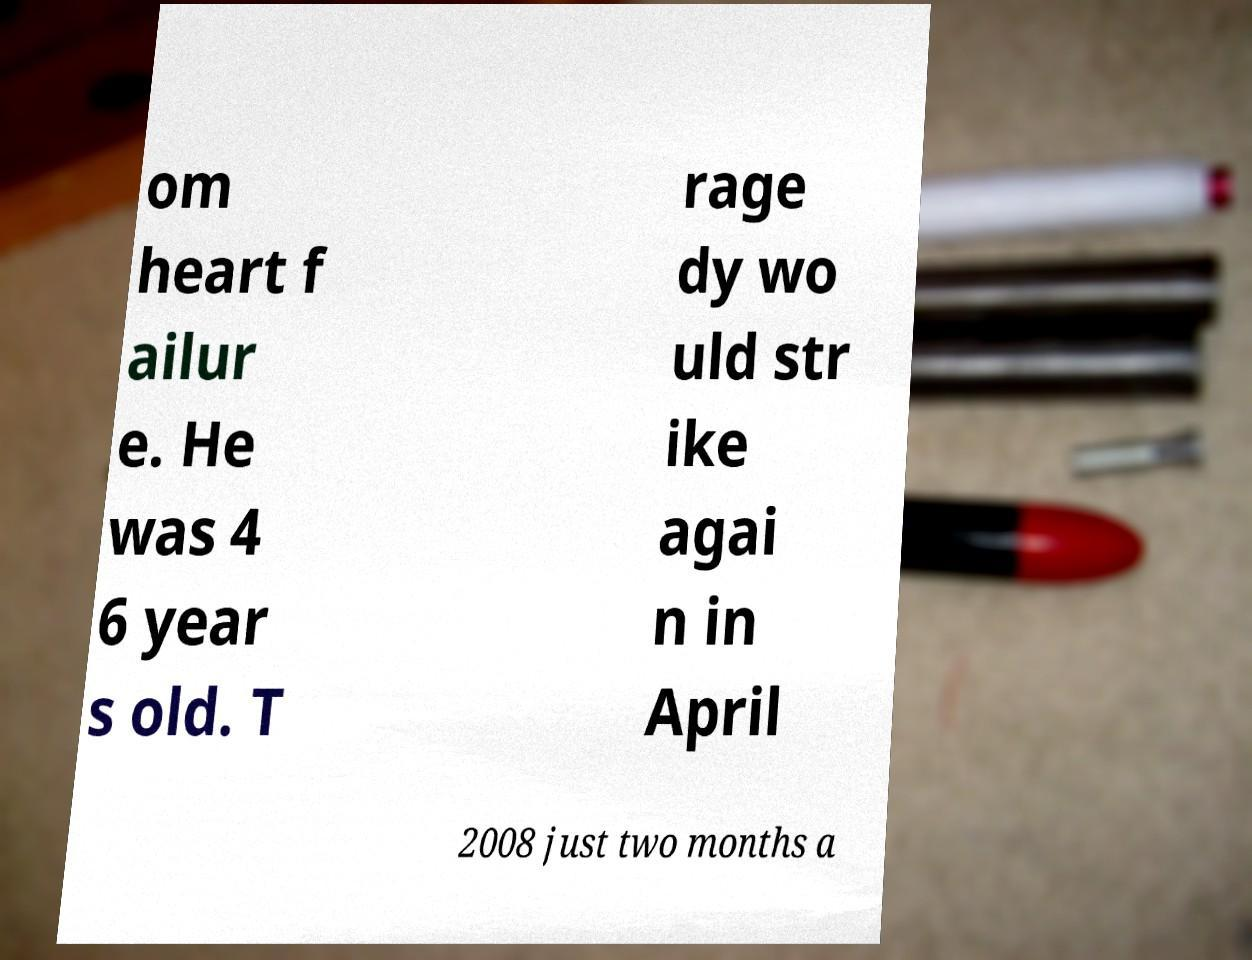Can you accurately transcribe the text from the provided image for me? om heart f ailur e. He was 4 6 year s old. T rage dy wo uld str ike agai n in April 2008 just two months a 